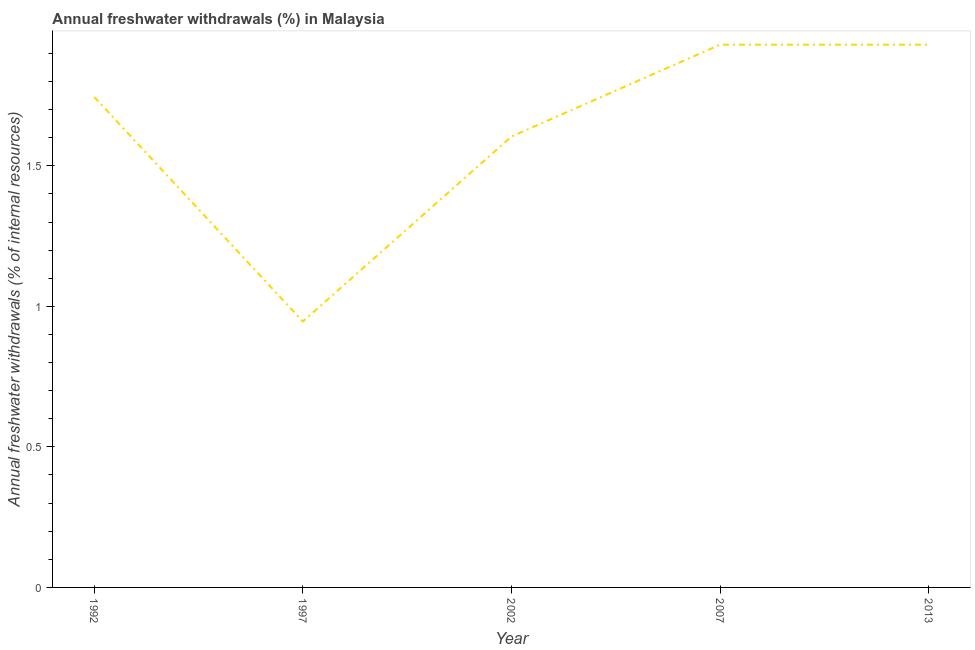What is the annual freshwater withdrawals in 2007?
Ensure brevity in your answer.  1.93. Across all years, what is the maximum annual freshwater withdrawals?
Provide a short and direct response. 1.93. Across all years, what is the minimum annual freshwater withdrawals?
Make the answer very short. 0.95. In which year was the annual freshwater withdrawals maximum?
Provide a succinct answer. 2007. What is the sum of the annual freshwater withdrawals?
Provide a succinct answer. 8.16. What is the difference between the annual freshwater withdrawals in 1992 and 2007?
Make the answer very short. -0.19. What is the average annual freshwater withdrawals per year?
Ensure brevity in your answer.  1.63. What is the median annual freshwater withdrawals?
Keep it short and to the point. 1.74. In how many years, is the annual freshwater withdrawals greater than 0.9 %?
Offer a very short reply. 5. What is the ratio of the annual freshwater withdrawals in 2002 to that in 2013?
Your response must be concise. 0.83. Is the difference between the annual freshwater withdrawals in 1992 and 2007 greater than the difference between any two years?
Your response must be concise. No. What is the difference between the highest and the second highest annual freshwater withdrawals?
Give a very brief answer. 0. Is the sum of the annual freshwater withdrawals in 1992 and 1997 greater than the maximum annual freshwater withdrawals across all years?
Make the answer very short. Yes. What is the difference between the highest and the lowest annual freshwater withdrawals?
Give a very brief answer. 0.98. In how many years, is the annual freshwater withdrawals greater than the average annual freshwater withdrawals taken over all years?
Provide a succinct answer. 3. What is the difference between two consecutive major ticks on the Y-axis?
Provide a short and direct response. 0.5. Does the graph contain any zero values?
Provide a succinct answer. No. Does the graph contain grids?
Provide a short and direct response. No. What is the title of the graph?
Offer a very short reply. Annual freshwater withdrawals (%) in Malaysia. What is the label or title of the X-axis?
Your answer should be compact. Year. What is the label or title of the Y-axis?
Make the answer very short. Annual freshwater withdrawals (% of internal resources). What is the Annual freshwater withdrawals (% of internal resources) in 1992?
Make the answer very short. 1.74. What is the Annual freshwater withdrawals (% of internal resources) of 1997?
Ensure brevity in your answer.  0.95. What is the Annual freshwater withdrawals (% of internal resources) in 2002?
Your answer should be compact. 1.6. What is the Annual freshwater withdrawals (% of internal resources) of 2007?
Offer a very short reply. 1.93. What is the Annual freshwater withdrawals (% of internal resources) in 2013?
Your answer should be very brief. 1.93. What is the difference between the Annual freshwater withdrawals (% of internal resources) in 1992 and 1997?
Make the answer very short. 0.8. What is the difference between the Annual freshwater withdrawals (% of internal resources) in 1992 and 2002?
Your answer should be compact. 0.14. What is the difference between the Annual freshwater withdrawals (% of internal resources) in 1992 and 2007?
Make the answer very short. -0.19. What is the difference between the Annual freshwater withdrawals (% of internal resources) in 1992 and 2013?
Provide a succinct answer. -0.19. What is the difference between the Annual freshwater withdrawals (% of internal resources) in 1997 and 2002?
Keep it short and to the point. -0.66. What is the difference between the Annual freshwater withdrawals (% of internal resources) in 1997 and 2007?
Give a very brief answer. -0.98. What is the difference between the Annual freshwater withdrawals (% of internal resources) in 1997 and 2013?
Ensure brevity in your answer.  -0.98. What is the difference between the Annual freshwater withdrawals (% of internal resources) in 2002 and 2007?
Offer a very short reply. -0.33. What is the difference between the Annual freshwater withdrawals (% of internal resources) in 2002 and 2013?
Provide a succinct answer. -0.33. What is the ratio of the Annual freshwater withdrawals (% of internal resources) in 1992 to that in 1997?
Your answer should be very brief. 1.84. What is the ratio of the Annual freshwater withdrawals (% of internal resources) in 1992 to that in 2002?
Your answer should be very brief. 1.09. What is the ratio of the Annual freshwater withdrawals (% of internal resources) in 1992 to that in 2007?
Your answer should be compact. 0.9. What is the ratio of the Annual freshwater withdrawals (% of internal resources) in 1992 to that in 2013?
Offer a very short reply. 0.9. What is the ratio of the Annual freshwater withdrawals (% of internal resources) in 1997 to that in 2002?
Offer a terse response. 0.59. What is the ratio of the Annual freshwater withdrawals (% of internal resources) in 1997 to that in 2007?
Provide a succinct answer. 0.49. What is the ratio of the Annual freshwater withdrawals (% of internal resources) in 1997 to that in 2013?
Provide a succinct answer. 0.49. What is the ratio of the Annual freshwater withdrawals (% of internal resources) in 2002 to that in 2007?
Offer a terse response. 0.83. What is the ratio of the Annual freshwater withdrawals (% of internal resources) in 2002 to that in 2013?
Your response must be concise. 0.83. What is the ratio of the Annual freshwater withdrawals (% of internal resources) in 2007 to that in 2013?
Your answer should be compact. 1. 